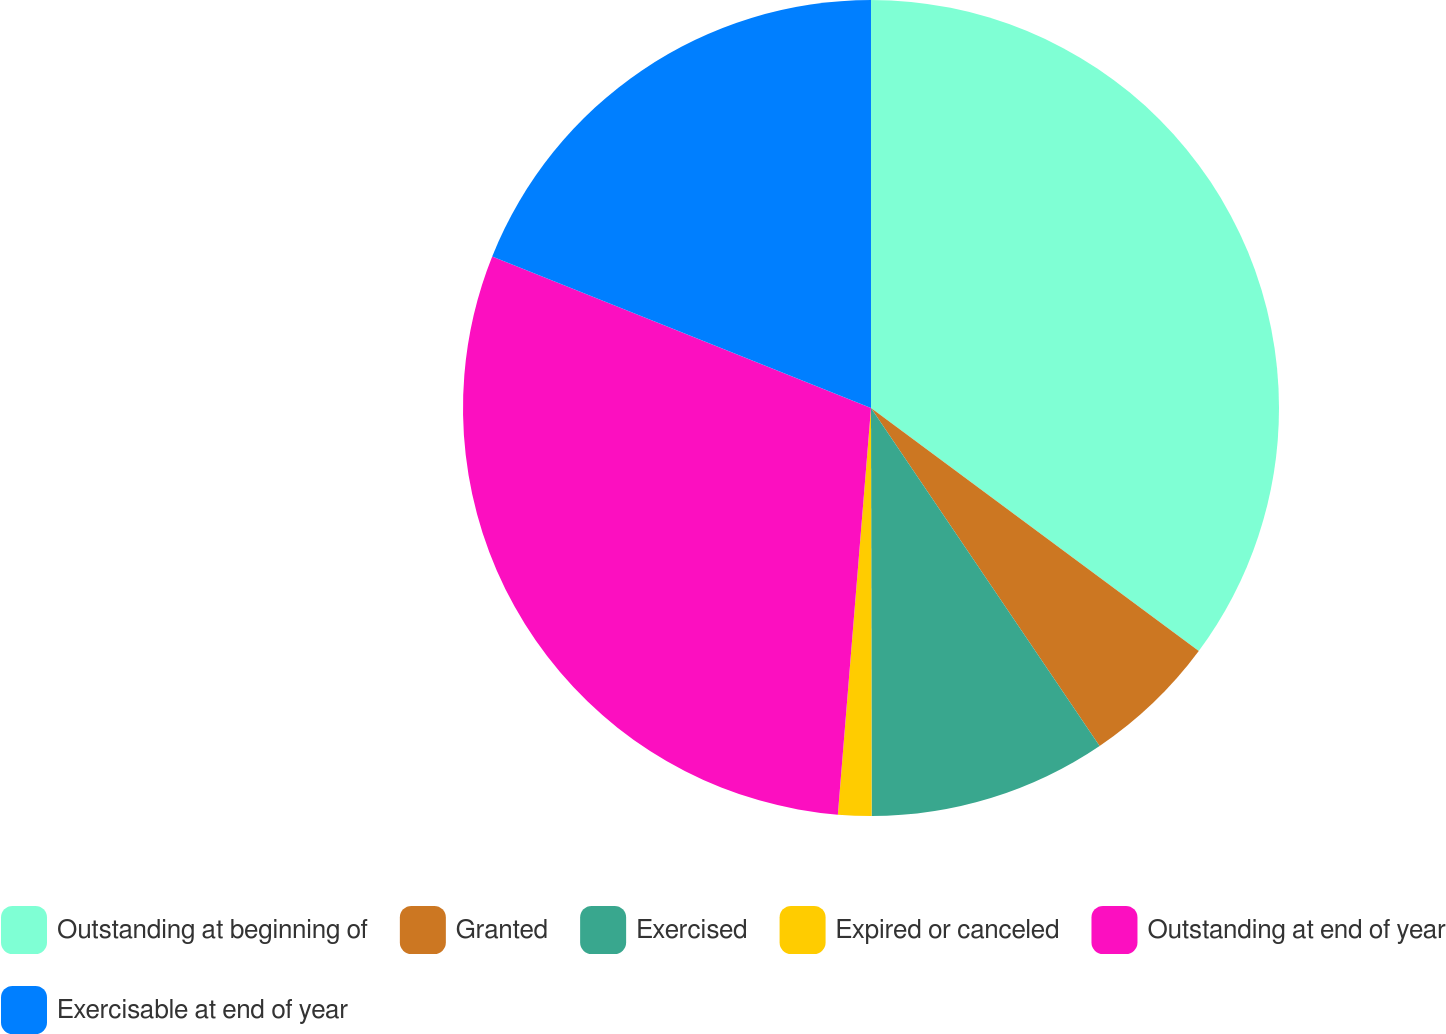Convert chart to OTSL. <chart><loc_0><loc_0><loc_500><loc_500><pie_chart><fcel>Outstanding at beginning of<fcel>Granted<fcel>Exercised<fcel>Expired or canceled<fcel>Outstanding at end of year<fcel>Exercisable at end of year<nl><fcel>35.15%<fcel>5.38%<fcel>9.44%<fcel>1.32%<fcel>29.76%<fcel>18.94%<nl></chart> 